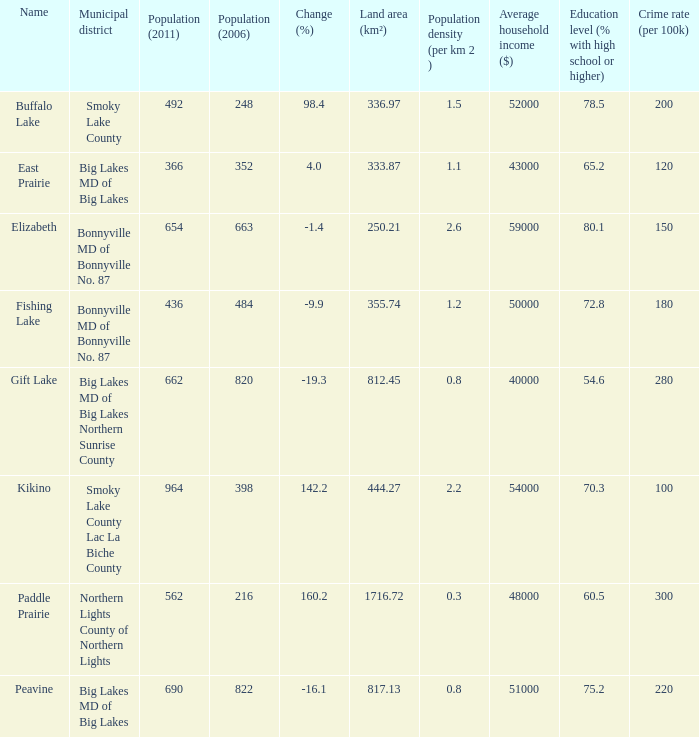What is the population per km in Smoky Lake County? 1.5. 